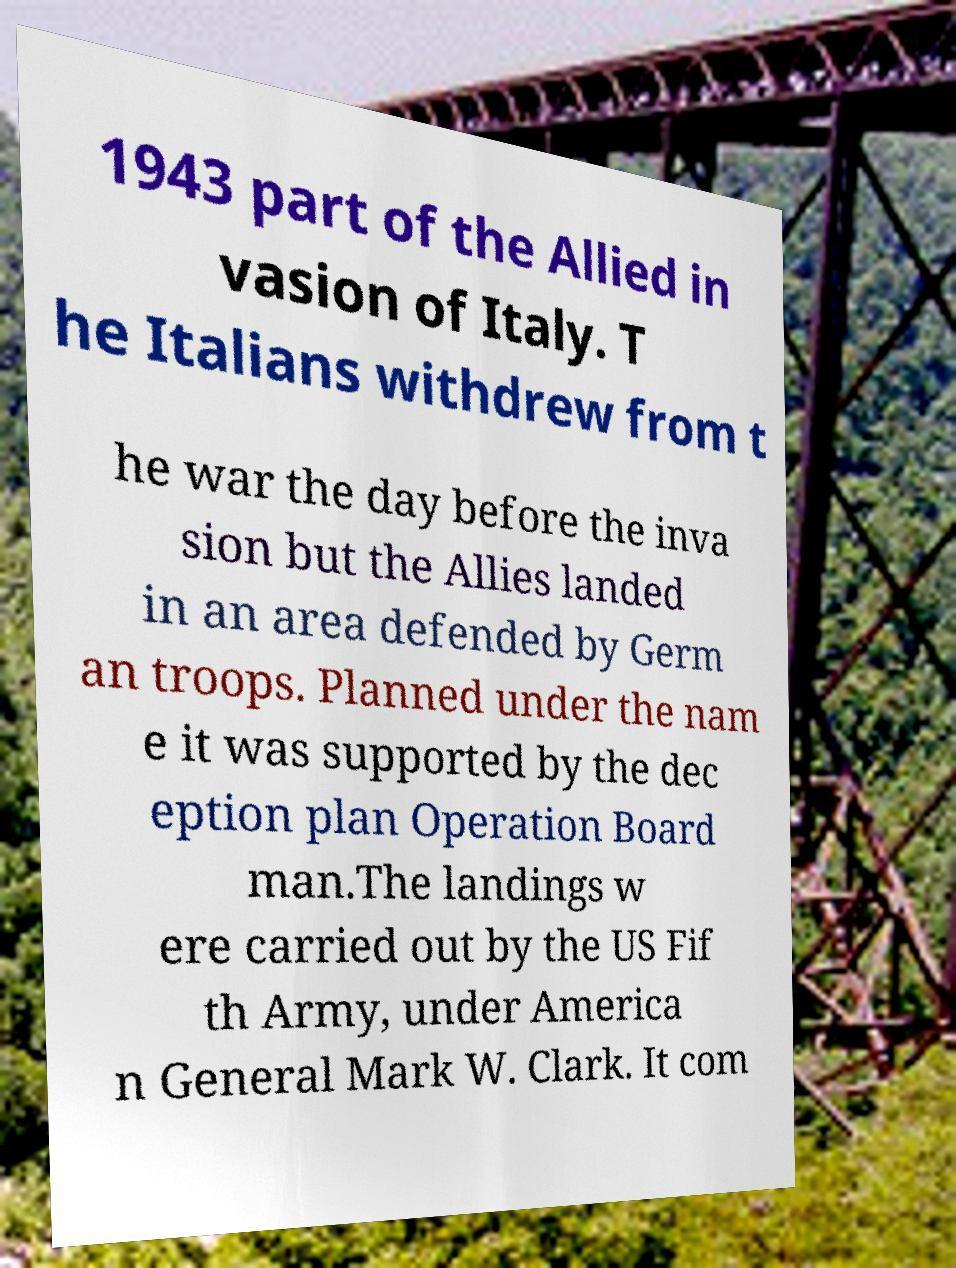I need the written content from this picture converted into text. Can you do that? 1943 part of the Allied in vasion of Italy. T he Italians withdrew from t he war the day before the inva sion but the Allies landed in an area defended by Germ an troops. Planned under the nam e it was supported by the dec eption plan Operation Board man.The landings w ere carried out by the US Fif th Army, under America n General Mark W. Clark. It com 